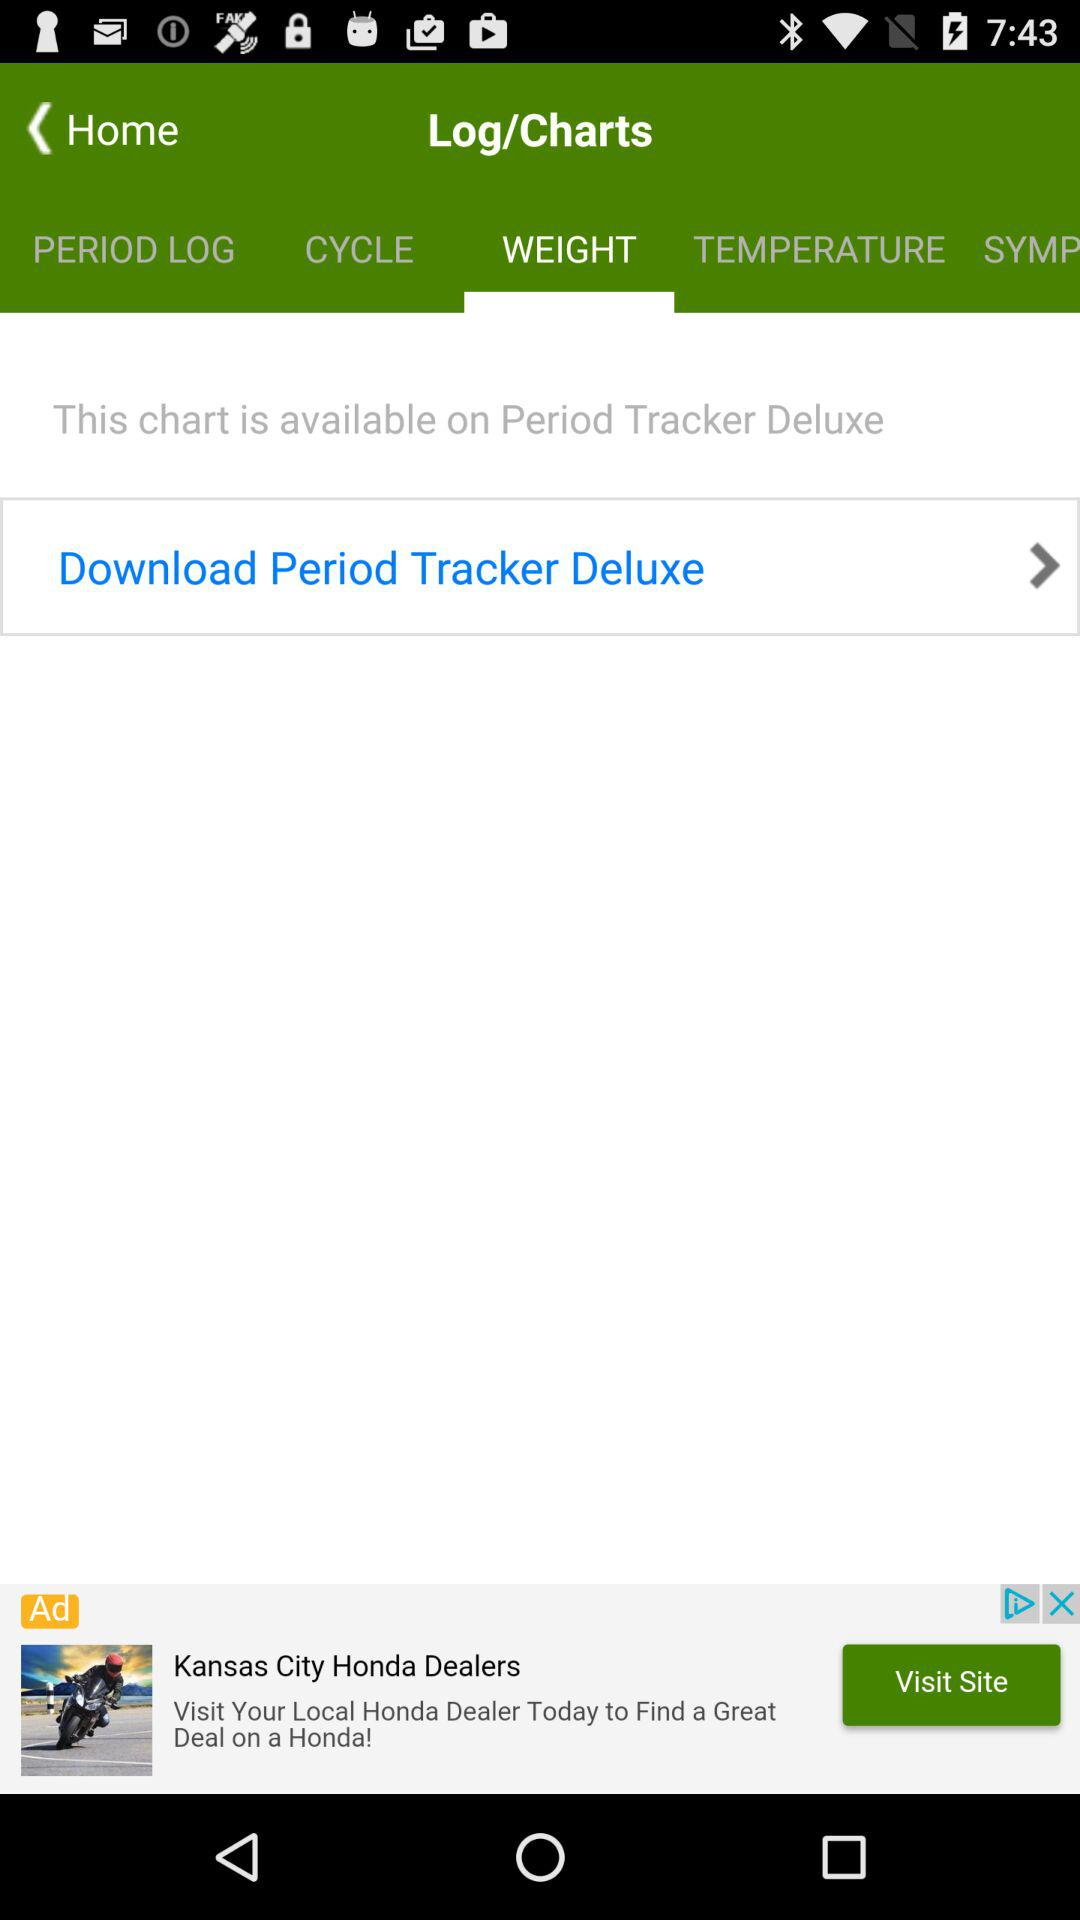Which tab is selected? The selected tab is "WEIGHT". 